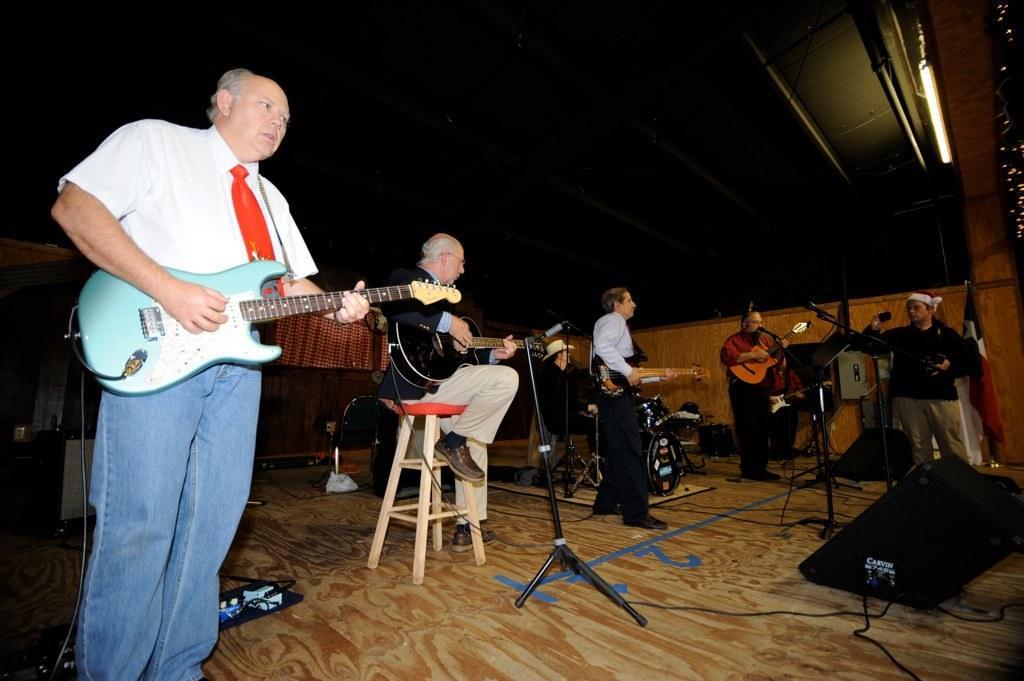How would you summarize this image in a sentence or two? In this image we can see a man wearing white shirt and blue jeans is holding a guitar in his hand and playing it. There are few more people holding guitar and playing it. This man in the background wearing a hat is playing the electronic drums. 